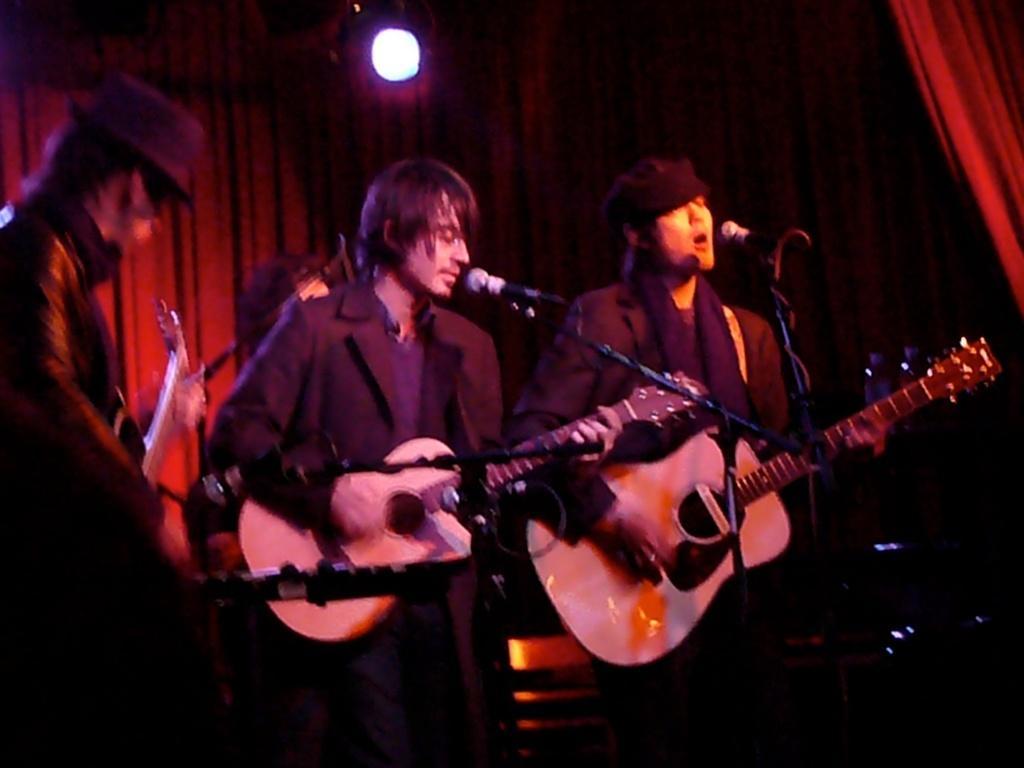Could you give a brief overview of what you see in this image? In this image I see 3 men and all of them are standing in front of the mics and they're holding the guitars. In the background I see the curtain and the light. 